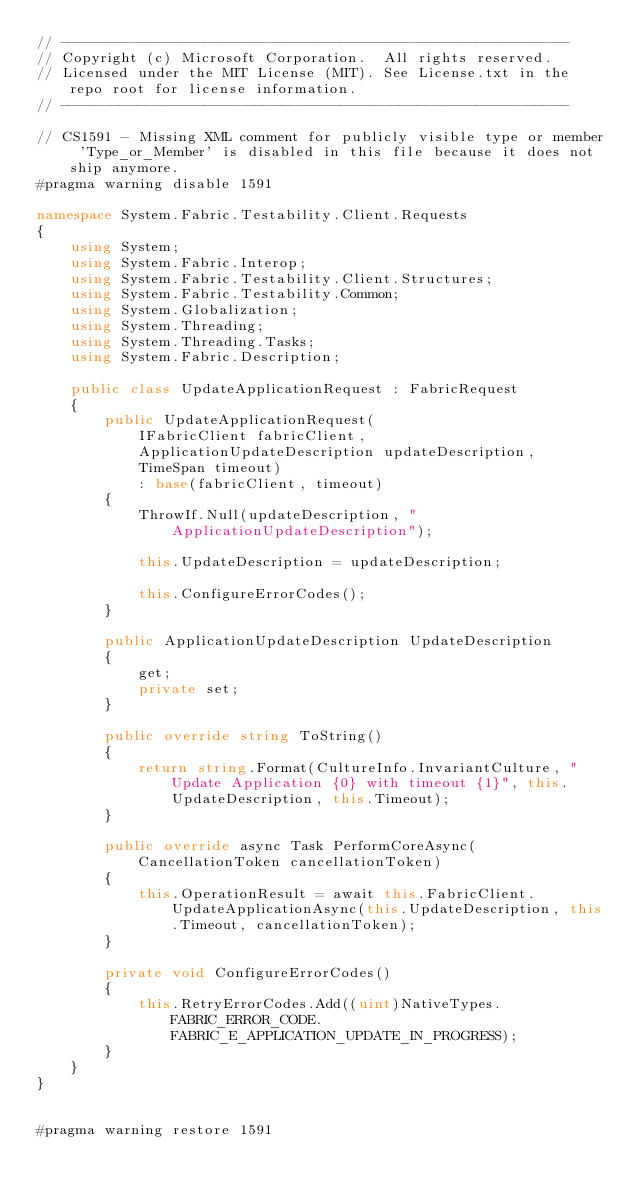Convert code to text. <code><loc_0><loc_0><loc_500><loc_500><_C#_>// ------------------------------------------------------------
// Copyright (c) Microsoft Corporation.  All rights reserved.
// Licensed under the MIT License (MIT). See License.txt in the repo root for license information.
// ------------------------------------------------------------

// CS1591 - Missing XML comment for publicly visible type or member 'Type_or_Member' is disabled in this file because it does not ship anymore.
#pragma warning disable 1591

namespace System.Fabric.Testability.Client.Requests
{
    using System;
    using System.Fabric.Interop;
    using System.Fabric.Testability.Client.Structures;
    using System.Fabric.Testability.Common;
    using System.Globalization;
    using System.Threading;
    using System.Threading.Tasks;
    using System.Fabric.Description;

    public class UpdateApplicationRequest : FabricRequest
    {
        public UpdateApplicationRequest(
            IFabricClient fabricClient,
            ApplicationUpdateDescription updateDescription,
            TimeSpan timeout)
            : base(fabricClient, timeout)
        {
            ThrowIf.Null(updateDescription, "ApplicationUpdateDescription");

            this.UpdateDescription = updateDescription;

            this.ConfigureErrorCodes();
        }

        public ApplicationUpdateDescription UpdateDescription
        {
            get;
            private set;
        }

        public override string ToString()
        {
            return string.Format(CultureInfo.InvariantCulture, "Update Application {0} with timeout {1}", this.UpdateDescription, this.Timeout);
        }

        public override async Task PerformCoreAsync(CancellationToken cancellationToken)
        {
            this.OperationResult = await this.FabricClient.UpdateApplicationAsync(this.UpdateDescription, this.Timeout, cancellationToken);
        }

        private void ConfigureErrorCodes()
        {
            this.RetryErrorCodes.Add((uint)NativeTypes.FABRIC_ERROR_CODE.FABRIC_E_APPLICATION_UPDATE_IN_PROGRESS);
        }
    }
}


#pragma warning restore 1591</code> 